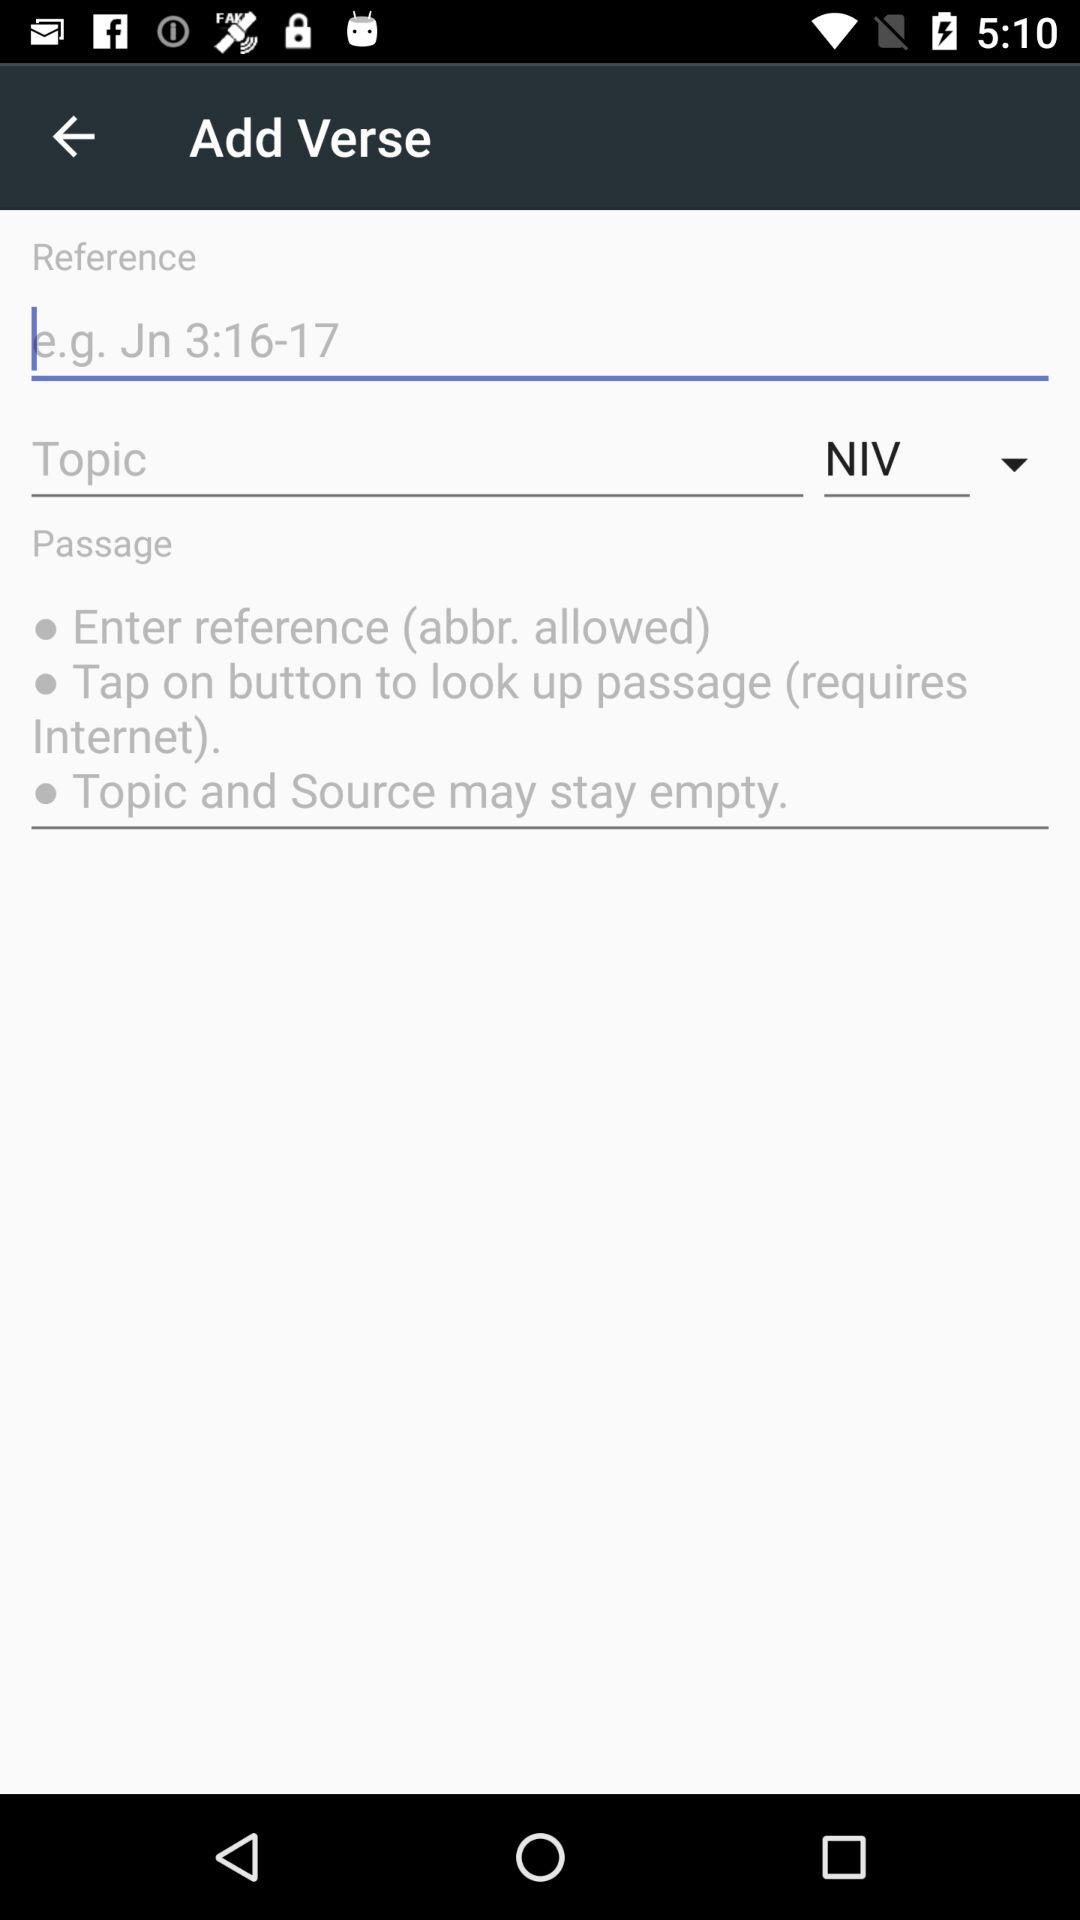What is the reference?
When the provided information is insufficient, respond with <no answer>. <no answer> 